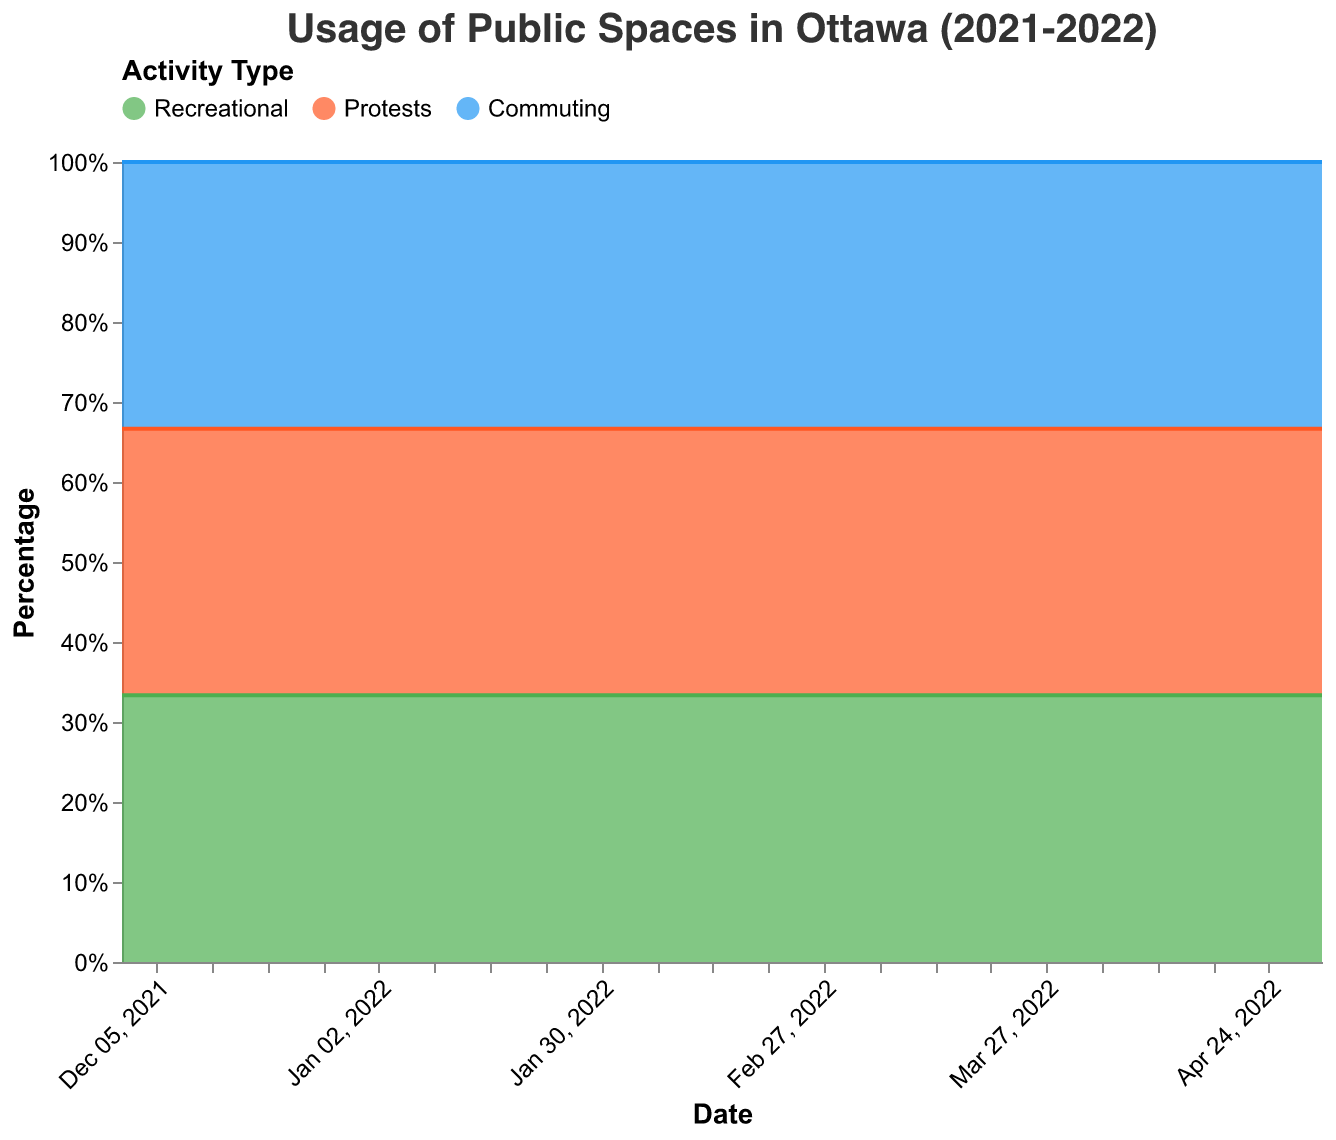What is the title of the figure? The title is usually found at the top of the figure and it summarizes what the chart is about.
Answer: Usage of Public Spaces in Ottawa (2021-2022) How did the percentage of recreational activities change from February 1, 2022 to February 20, 2022? Look at the percentage of recreational activities on February 1 (30%), and compare it to February 20 (15%). The difference is 30% - 15%.
Answer: Decreased by 15% What activities dominated public space usage in February 2022? In February 2022, the area representing protests is the largest in comparison to recreational and commuting, as seen in the topmost layer of the stacked area chart.
Answer: Protests By what percentage did recreational activities increase from February 20, 2022, to March 1, 2022? On February 20, 2022, the recreational percentage was 15%, and on March 1, 2022, it was 50%. The increase is calculated as 50% - 15%.
Answer: 35% Compare the percentage of commuting activities before and after the convoy (January 15, 2022, and March 1, 2022). What is the difference? The percentage on January 15, 2022, was 43%, and on March 1, 2022, it was 45%. The difference is 45% - 43%.
Answer: Increased by 2% What was the peak percentage of protests during the Freedom Convoy and on which date did it occur? The peak percentage of protests occurred when the protest area was the largest. The highest point occurred on February 20, 2022, with 75%.
Answer: 75% on February 20, 2022 How did the percentage of commuting activities change from December 1, 2021, to January 1, 2022? The percentage of commuting on December 1, 2021, was 40%, and on January 1, 2022, it was 42%. The change is 42% - 40%.
Answer: Increased by 2% Which activity had the smallest usage post the convoy in April 2022? In April 2022, the areas of recreational, protests, and commuting show that the smallest area is for protests, as it is at the bottom of the stack.
Answer: Protests What is the relative change in percentages of recreational activities from the pre-convoy period (January 1, 2022) to the post-convoy period (May 1, 2022)? The recreational percentage was 58% on January 1, 2022, and 65% on May 1, 2022. The relative change = (65% - 58%)/58% and multiply by 100 for percentage.
Answer: 12.1% What is the median percentage of recreational activities from December 1, 2021, to May 1, 2022? To find the median, list out the percentages of recreational activities: [60%, 55%, 58%, 57%, 30%, 25%, 20%, 18%, 15%, 50%, 52%, 55%, 60%, 65%], and find the middle value. For 14 values, the median is between the 7th and 8th values: 32.5%.
Answer: 32.5% 